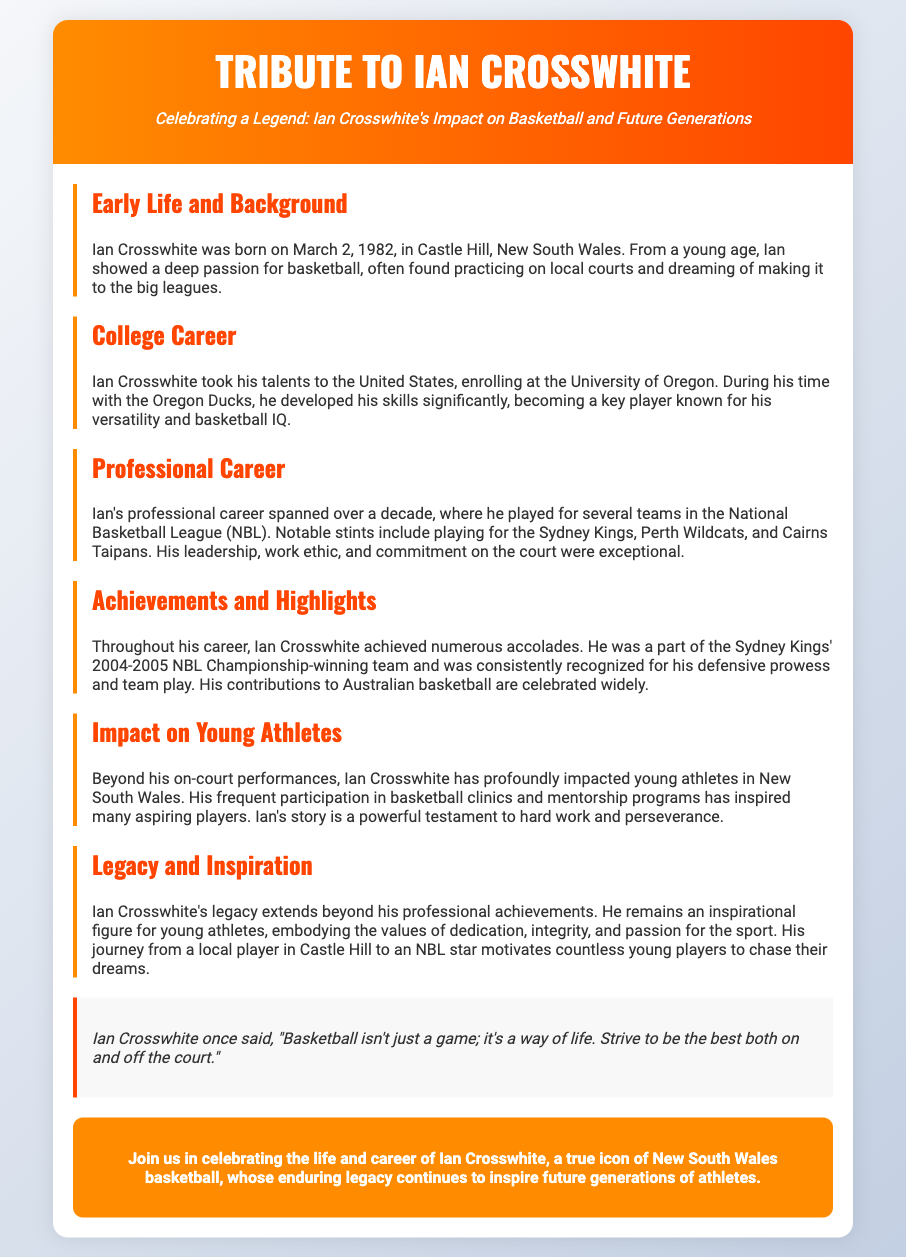What is Ian Crosswhite's birth date? Ian Crosswhite was born on March 2, 1982, as stated in the Early Life and Background section.
Answer: March 2, 1982 Which university did Ian Crosswhite attend? The document mentions that Ian Commonplace attended the University of Oregon during his college career.
Answer: University of Oregon How many teams did Ian Crosswhite play for in the NBL? The Professional Career section indicates that Ian played for several teams, including Sydney Kings, Perth Wildcats, and Cairns Taipans, meaning he played for three key teams.
Answer: Three What championship did Ian Crosswhite win? The Achievements and Highlights section states that Ian was part of the Sydney Kings' 2004-2005 NBL Championship-winning team.
Answer: 2004-2005 NBL Championship What is one of Ian Crosswhite's key impacts on young athletes? The document highlights Ian's frequent participation in basketball clinics and mentorship programs that inspire aspiring players.
Answer: Mentorship programs What qualities does Ian Crosswhite embody according to the Legacy section? The Legacy and Inspiration section discusses that Ian embodies dedication, integrity, and passion for the sport.
Answer: Dedication, integrity, passion What is the main focus of this Playbill? The title and content clearly indicate that the focus is on celebrating Ian Crosswhite's impact on basketball and future generations.
Answer: Celebrating Ian Crosswhite Who is the intended audience for this tribute? The document highlights that Ian's legacy is directed towards inspiring young athletes, suggesting that they are the primary audience.
Answer: Young athletes 